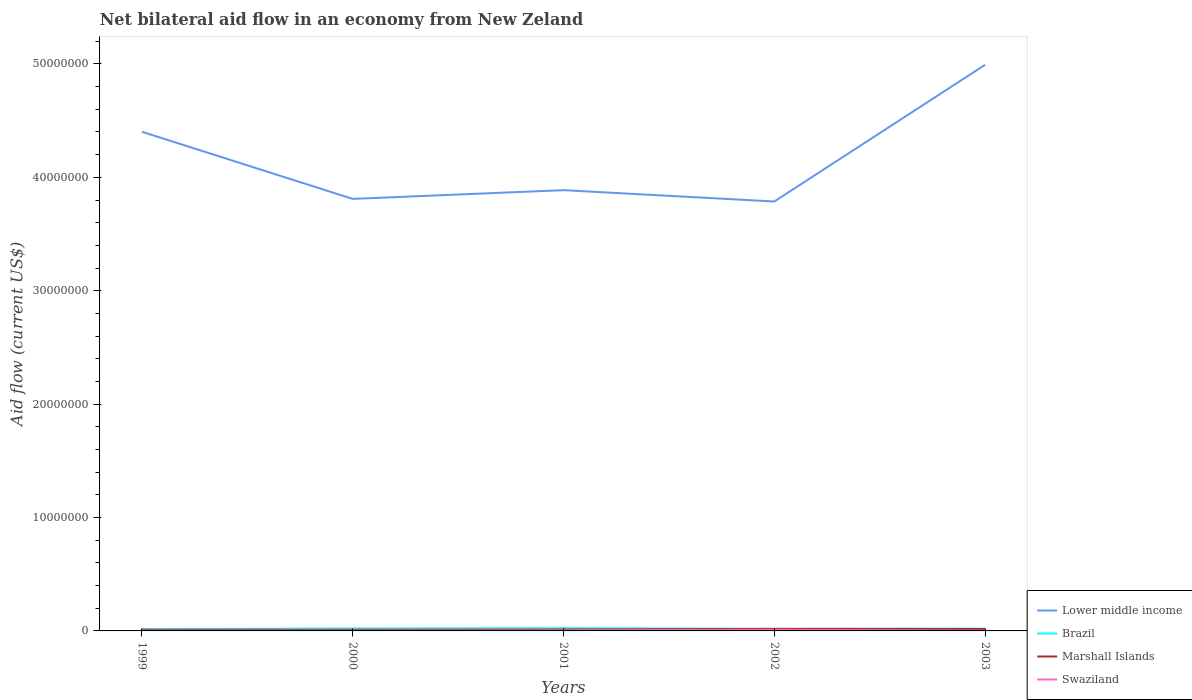How many different coloured lines are there?
Provide a short and direct response. 4. Does the line corresponding to Swaziland intersect with the line corresponding to Lower middle income?
Keep it short and to the point. No. Across all years, what is the maximum net bilateral aid flow in Swaziland?
Ensure brevity in your answer.  2.00e+04. In which year was the net bilateral aid flow in Lower middle income maximum?
Make the answer very short. 2002. What is the total net bilateral aid flow in Lower middle income in the graph?
Provide a short and direct response. -1.10e+07. What is the difference between the highest and the second highest net bilateral aid flow in Brazil?
Provide a succinct answer. 7.00e+04. What is the difference between the highest and the lowest net bilateral aid flow in Lower middle income?
Offer a very short reply. 2. Is the net bilateral aid flow in Swaziland strictly greater than the net bilateral aid flow in Lower middle income over the years?
Provide a short and direct response. Yes. How many lines are there?
Keep it short and to the point. 4. How many years are there in the graph?
Keep it short and to the point. 5. Does the graph contain any zero values?
Provide a succinct answer. No. Where does the legend appear in the graph?
Your answer should be compact. Bottom right. What is the title of the graph?
Provide a succinct answer. Net bilateral aid flow in an economy from New Zeland. Does "Nepal" appear as one of the legend labels in the graph?
Your answer should be compact. No. What is the label or title of the Y-axis?
Give a very brief answer. Aid flow (current US$). What is the Aid flow (current US$) in Lower middle income in 1999?
Keep it short and to the point. 4.40e+07. What is the Aid flow (current US$) of Brazil in 1999?
Your response must be concise. 1.70e+05. What is the Aid flow (current US$) of Marshall Islands in 1999?
Your answer should be compact. 1.00e+05. What is the Aid flow (current US$) of Lower middle income in 2000?
Ensure brevity in your answer.  3.81e+07. What is the Aid flow (current US$) in Marshall Islands in 2000?
Keep it short and to the point. 1.00e+05. What is the Aid flow (current US$) in Lower middle income in 2001?
Give a very brief answer. 3.89e+07. What is the Aid flow (current US$) of Brazil in 2001?
Give a very brief answer. 2.40e+05. What is the Aid flow (current US$) in Swaziland in 2001?
Provide a short and direct response. 5.00e+04. What is the Aid flow (current US$) of Lower middle income in 2002?
Make the answer very short. 3.79e+07. What is the Aid flow (current US$) in Brazil in 2002?
Provide a short and direct response. 1.80e+05. What is the Aid flow (current US$) of Marshall Islands in 2002?
Offer a very short reply. 1.80e+05. What is the Aid flow (current US$) in Swaziland in 2002?
Your answer should be very brief. 1.00e+05. What is the Aid flow (current US$) in Lower middle income in 2003?
Provide a short and direct response. 4.99e+07. Across all years, what is the maximum Aid flow (current US$) in Lower middle income?
Keep it short and to the point. 4.99e+07. Across all years, what is the maximum Aid flow (current US$) of Brazil?
Your answer should be compact. 2.40e+05. Across all years, what is the minimum Aid flow (current US$) of Lower middle income?
Your answer should be very brief. 3.79e+07. Across all years, what is the minimum Aid flow (current US$) in Marshall Islands?
Provide a short and direct response. 1.00e+05. What is the total Aid flow (current US$) in Lower middle income in the graph?
Make the answer very short. 2.09e+08. What is the total Aid flow (current US$) of Marshall Islands in the graph?
Provide a short and direct response. 6.70e+05. What is the total Aid flow (current US$) of Swaziland in the graph?
Keep it short and to the point. 2.30e+05. What is the difference between the Aid flow (current US$) of Lower middle income in 1999 and that in 2000?
Your answer should be very brief. 5.92e+06. What is the difference between the Aid flow (current US$) in Brazil in 1999 and that in 2000?
Offer a terse response. -4.00e+04. What is the difference between the Aid flow (current US$) of Marshall Islands in 1999 and that in 2000?
Ensure brevity in your answer.  0. What is the difference between the Aid flow (current US$) in Swaziland in 1999 and that in 2000?
Offer a terse response. 0. What is the difference between the Aid flow (current US$) of Lower middle income in 1999 and that in 2001?
Make the answer very short. 5.15e+06. What is the difference between the Aid flow (current US$) in Brazil in 1999 and that in 2001?
Give a very brief answer. -7.00e+04. What is the difference between the Aid flow (current US$) in Marshall Islands in 1999 and that in 2001?
Your answer should be compact. -2.00e+04. What is the difference between the Aid flow (current US$) in Lower middle income in 1999 and that in 2002?
Keep it short and to the point. 6.15e+06. What is the difference between the Aid flow (current US$) in Lower middle income in 1999 and that in 2003?
Your answer should be compact. -5.90e+06. What is the difference between the Aid flow (current US$) of Brazil in 1999 and that in 2003?
Your response must be concise. -3.00e+04. What is the difference between the Aid flow (current US$) in Lower middle income in 2000 and that in 2001?
Provide a short and direct response. -7.70e+05. What is the difference between the Aid flow (current US$) in Brazil in 2000 and that in 2001?
Your response must be concise. -3.00e+04. What is the difference between the Aid flow (current US$) of Marshall Islands in 2000 and that in 2001?
Your answer should be very brief. -2.00e+04. What is the difference between the Aid flow (current US$) of Lower middle income in 2000 and that in 2002?
Give a very brief answer. 2.30e+05. What is the difference between the Aid flow (current US$) of Swaziland in 2000 and that in 2002?
Ensure brevity in your answer.  -7.00e+04. What is the difference between the Aid flow (current US$) in Lower middle income in 2000 and that in 2003?
Your answer should be compact. -1.18e+07. What is the difference between the Aid flow (current US$) in Marshall Islands in 2000 and that in 2003?
Provide a succinct answer. -7.00e+04. What is the difference between the Aid flow (current US$) of Lower middle income in 2001 and that in 2002?
Ensure brevity in your answer.  1.00e+06. What is the difference between the Aid flow (current US$) of Marshall Islands in 2001 and that in 2002?
Offer a very short reply. -6.00e+04. What is the difference between the Aid flow (current US$) in Swaziland in 2001 and that in 2002?
Keep it short and to the point. -5.00e+04. What is the difference between the Aid flow (current US$) in Lower middle income in 2001 and that in 2003?
Give a very brief answer. -1.10e+07. What is the difference between the Aid flow (current US$) of Lower middle income in 2002 and that in 2003?
Provide a short and direct response. -1.20e+07. What is the difference between the Aid flow (current US$) of Marshall Islands in 2002 and that in 2003?
Ensure brevity in your answer.  10000. What is the difference between the Aid flow (current US$) in Swaziland in 2002 and that in 2003?
Offer a terse response. 8.00e+04. What is the difference between the Aid flow (current US$) in Lower middle income in 1999 and the Aid flow (current US$) in Brazil in 2000?
Your response must be concise. 4.38e+07. What is the difference between the Aid flow (current US$) of Lower middle income in 1999 and the Aid flow (current US$) of Marshall Islands in 2000?
Provide a short and direct response. 4.39e+07. What is the difference between the Aid flow (current US$) in Lower middle income in 1999 and the Aid flow (current US$) in Swaziland in 2000?
Make the answer very short. 4.40e+07. What is the difference between the Aid flow (current US$) of Brazil in 1999 and the Aid flow (current US$) of Marshall Islands in 2000?
Provide a short and direct response. 7.00e+04. What is the difference between the Aid flow (current US$) of Brazil in 1999 and the Aid flow (current US$) of Swaziland in 2000?
Offer a very short reply. 1.40e+05. What is the difference between the Aid flow (current US$) in Lower middle income in 1999 and the Aid flow (current US$) in Brazil in 2001?
Your response must be concise. 4.38e+07. What is the difference between the Aid flow (current US$) in Lower middle income in 1999 and the Aid flow (current US$) in Marshall Islands in 2001?
Your response must be concise. 4.39e+07. What is the difference between the Aid flow (current US$) in Lower middle income in 1999 and the Aid flow (current US$) in Swaziland in 2001?
Your answer should be very brief. 4.40e+07. What is the difference between the Aid flow (current US$) in Brazil in 1999 and the Aid flow (current US$) in Marshall Islands in 2001?
Give a very brief answer. 5.00e+04. What is the difference between the Aid flow (current US$) of Lower middle income in 1999 and the Aid flow (current US$) of Brazil in 2002?
Your answer should be compact. 4.38e+07. What is the difference between the Aid flow (current US$) in Lower middle income in 1999 and the Aid flow (current US$) in Marshall Islands in 2002?
Provide a succinct answer. 4.38e+07. What is the difference between the Aid flow (current US$) in Lower middle income in 1999 and the Aid flow (current US$) in Swaziland in 2002?
Provide a short and direct response. 4.39e+07. What is the difference between the Aid flow (current US$) in Brazil in 1999 and the Aid flow (current US$) in Marshall Islands in 2002?
Offer a very short reply. -10000. What is the difference between the Aid flow (current US$) in Marshall Islands in 1999 and the Aid flow (current US$) in Swaziland in 2002?
Make the answer very short. 0. What is the difference between the Aid flow (current US$) in Lower middle income in 1999 and the Aid flow (current US$) in Brazil in 2003?
Ensure brevity in your answer.  4.38e+07. What is the difference between the Aid flow (current US$) of Lower middle income in 1999 and the Aid flow (current US$) of Marshall Islands in 2003?
Make the answer very short. 4.38e+07. What is the difference between the Aid flow (current US$) in Lower middle income in 1999 and the Aid flow (current US$) in Swaziland in 2003?
Your answer should be very brief. 4.40e+07. What is the difference between the Aid flow (current US$) in Brazil in 1999 and the Aid flow (current US$) in Swaziland in 2003?
Ensure brevity in your answer.  1.50e+05. What is the difference between the Aid flow (current US$) in Lower middle income in 2000 and the Aid flow (current US$) in Brazil in 2001?
Your response must be concise. 3.79e+07. What is the difference between the Aid flow (current US$) of Lower middle income in 2000 and the Aid flow (current US$) of Marshall Islands in 2001?
Your answer should be compact. 3.80e+07. What is the difference between the Aid flow (current US$) in Lower middle income in 2000 and the Aid flow (current US$) in Swaziland in 2001?
Your response must be concise. 3.80e+07. What is the difference between the Aid flow (current US$) of Marshall Islands in 2000 and the Aid flow (current US$) of Swaziland in 2001?
Your answer should be compact. 5.00e+04. What is the difference between the Aid flow (current US$) in Lower middle income in 2000 and the Aid flow (current US$) in Brazil in 2002?
Keep it short and to the point. 3.79e+07. What is the difference between the Aid flow (current US$) of Lower middle income in 2000 and the Aid flow (current US$) of Marshall Islands in 2002?
Your answer should be very brief. 3.79e+07. What is the difference between the Aid flow (current US$) of Lower middle income in 2000 and the Aid flow (current US$) of Swaziland in 2002?
Keep it short and to the point. 3.80e+07. What is the difference between the Aid flow (current US$) of Lower middle income in 2000 and the Aid flow (current US$) of Brazil in 2003?
Provide a short and direct response. 3.79e+07. What is the difference between the Aid flow (current US$) of Lower middle income in 2000 and the Aid flow (current US$) of Marshall Islands in 2003?
Offer a terse response. 3.79e+07. What is the difference between the Aid flow (current US$) of Lower middle income in 2000 and the Aid flow (current US$) of Swaziland in 2003?
Keep it short and to the point. 3.81e+07. What is the difference between the Aid flow (current US$) in Brazil in 2000 and the Aid flow (current US$) in Marshall Islands in 2003?
Your response must be concise. 4.00e+04. What is the difference between the Aid flow (current US$) in Brazil in 2000 and the Aid flow (current US$) in Swaziland in 2003?
Your response must be concise. 1.90e+05. What is the difference between the Aid flow (current US$) of Marshall Islands in 2000 and the Aid flow (current US$) of Swaziland in 2003?
Give a very brief answer. 8.00e+04. What is the difference between the Aid flow (current US$) in Lower middle income in 2001 and the Aid flow (current US$) in Brazil in 2002?
Give a very brief answer. 3.87e+07. What is the difference between the Aid flow (current US$) of Lower middle income in 2001 and the Aid flow (current US$) of Marshall Islands in 2002?
Give a very brief answer. 3.87e+07. What is the difference between the Aid flow (current US$) of Lower middle income in 2001 and the Aid flow (current US$) of Swaziland in 2002?
Your answer should be compact. 3.88e+07. What is the difference between the Aid flow (current US$) in Marshall Islands in 2001 and the Aid flow (current US$) in Swaziland in 2002?
Your response must be concise. 2.00e+04. What is the difference between the Aid flow (current US$) in Lower middle income in 2001 and the Aid flow (current US$) in Brazil in 2003?
Your answer should be very brief. 3.87e+07. What is the difference between the Aid flow (current US$) of Lower middle income in 2001 and the Aid flow (current US$) of Marshall Islands in 2003?
Provide a short and direct response. 3.87e+07. What is the difference between the Aid flow (current US$) of Lower middle income in 2001 and the Aid flow (current US$) of Swaziland in 2003?
Offer a terse response. 3.88e+07. What is the difference between the Aid flow (current US$) of Brazil in 2001 and the Aid flow (current US$) of Marshall Islands in 2003?
Keep it short and to the point. 7.00e+04. What is the difference between the Aid flow (current US$) of Brazil in 2001 and the Aid flow (current US$) of Swaziland in 2003?
Offer a very short reply. 2.20e+05. What is the difference between the Aid flow (current US$) of Marshall Islands in 2001 and the Aid flow (current US$) of Swaziland in 2003?
Your answer should be compact. 1.00e+05. What is the difference between the Aid flow (current US$) in Lower middle income in 2002 and the Aid flow (current US$) in Brazil in 2003?
Offer a terse response. 3.77e+07. What is the difference between the Aid flow (current US$) in Lower middle income in 2002 and the Aid flow (current US$) in Marshall Islands in 2003?
Your response must be concise. 3.77e+07. What is the difference between the Aid flow (current US$) of Lower middle income in 2002 and the Aid flow (current US$) of Swaziland in 2003?
Make the answer very short. 3.78e+07. What is the difference between the Aid flow (current US$) of Brazil in 2002 and the Aid flow (current US$) of Marshall Islands in 2003?
Offer a terse response. 10000. What is the difference between the Aid flow (current US$) of Marshall Islands in 2002 and the Aid flow (current US$) of Swaziland in 2003?
Offer a very short reply. 1.60e+05. What is the average Aid flow (current US$) in Lower middle income per year?
Your response must be concise. 4.18e+07. What is the average Aid flow (current US$) in Marshall Islands per year?
Your answer should be very brief. 1.34e+05. What is the average Aid flow (current US$) in Swaziland per year?
Offer a terse response. 4.60e+04. In the year 1999, what is the difference between the Aid flow (current US$) of Lower middle income and Aid flow (current US$) of Brazil?
Offer a terse response. 4.38e+07. In the year 1999, what is the difference between the Aid flow (current US$) in Lower middle income and Aid flow (current US$) in Marshall Islands?
Provide a short and direct response. 4.39e+07. In the year 1999, what is the difference between the Aid flow (current US$) in Lower middle income and Aid flow (current US$) in Swaziland?
Your answer should be very brief. 4.40e+07. In the year 1999, what is the difference between the Aid flow (current US$) in Brazil and Aid flow (current US$) in Marshall Islands?
Provide a short and direct response. 7.00e+04. In the year 2000, what is the difference between the Aid flow (current US$) of Lower middle income and Aid flow (current US$) of Brazil?
Keep it short and to the point. 3.79e+07. In the year 2000, what is the difference between the Aid flow (current US$) of Lower middle income and Aid flow (current US$) of Marshall Islands?
Offer a terse response. 3.80e+07. In the year 2000, what is the difference between the Aid flow (current US$) of Lower middle income and Aid flow (current US$) of Swaziland?
Offer a terse response. 3.81e+07. In the year 2000, what is the difference between the Aid flow (current US$) of Brazil and Aid flow (current US$) of Swaziland?
Provide a short and direct response. 1.80e+05. In the year 2000, what is the difference between the Aid flow (current US$) of Marshall Islands and Aid flow (current US$) of Swaziland?
Give a very brief answer. 7.00e+04. In the year 2001, what is the difference between the Aid flow (current US$) of Lower middle income and Aid flow (current US$) of Brazil?
Make the answer very short. 3.86e+07. In the year 2001, what is the difference between the Aid flow (current US$) in Lower middle income and Aid flow (current US$) in Marshall Islands?
Keep it short and to the point. 3.88e+07. In the year 2001, what is the difference between the Aid flow (current US$) of Lower middle income and Aid flow (current US$) of Swaziland?
Your answer should be very brief. 3.88e+07. In the year 2001, what is the difference between the Aid flow (current US$) in Marshall Islands and Aid flow (current US$) in Swaziland?
Provide a succinct answer. 7.00e+04. In the year 2002, what is the difference between the Aid flow (current US$) of Lower middle income and Aid flow (current US$) of Brazil?
Your response must be concise. 3.77e+07. In the year 2002, what is the difference between the Aid flow (current US$) of Lower middle income and Aid flow (current US$) of Marshall Islands?
Offer a very short reply. 3.77e+07. In the year 2002, what is the difference between the Aid flow (current US$) of Lower middle income and Aid flow (current US$) of Swaziland?
Your answer should be compact. 3.78e+07. In the year 2002, what is the difference between the Aid flow (current US$) of Brazil and Aid flow (current US$) of Marshall Islands?
Ensure brevity in your answer.  0. In the year 2002, what is the difference between the Aid flow (current US$) in Brazil and Aid flow (current US$) in Swaziland?
Your answer should be compact. 8.00e+04. In the year 2002, what is the difference between the Aid flow (current US$) in Marshall Islands and Aid flow (current US$) in Swaziland?
Provide a succinct answer. 8.00e+04. In the year 2003, what is the difference between the Aid flow (current US$) of Lower middle income and Aid flow (current US$) of Brazil?
Make the answer very short. 4.97e+07. In the year 2003, what is the difference between the Aid flow (current US$) of Lower middle income and Aid flow (current US$) of Marshall Islands?
Your response must be concise. 4.98e+07. In the year 2003, what is the difference between the Aid flow (current US$) in Lower middle income and Aid flow (current US$) in Swaziland?
Ensure brevity in your answer.  4.99e+07. In the year 2003, what is the difference between the Aid flow (current US$) in Brazil and Aid flow (current US$) in Marshall Islands?
Provide a succinct answer. 3.00e+04. In the year 2003, what is the difference between the Aid flow (current US$) of Brazil and Aid flow (current US$) of Swaziland?
Offer a very short reply. 1.80e+05. In the year 2003, what is the difference between the Aid flow (current US$) of Marshall Islands and Aid flow (current US$) of Swaziland?
Give a very brief answer. 1.50e+05. What is the ratio of the Aid flow (current US$) in Lower middle income in 1999 to that in 2000?
Provide a succinct answer. 1.16. What is the ratio of the Aid flow (current US$) in Brazil in 1999 to that in 2000?
Your response must be concise. 0.81. What is the ratio of the Aid flow (current US$) of Lower middle income in 1999 to that in 2001?
Offer a very short reply. 1.13. What is the ratio of the Aid flow (current US$) of Brazil in 1999 to that in 2001?
Provide a short and direct response. 0.71. What is the ratio of the Aid flow (current US$) in Lower middle income in 1999 to that in 2002?
Your response must be concise. 1.16. What is the ratio of the Aid flow (current US$) of Brazil in 1999 to that in 2002?
Offer a terse response. 0.94. What is the ratio of the Aid flow (current US$) in Marshall Islands in 1999 to that in 2002?
Ensure brevity in your answer.  0.56. What is the ratio of the Aid flow (current US$) in Swaziland in 1999 to that in 2002?
Provide a short and direct response. 0.3. What is the ratio of the Aid flow (current US$) of Lower middle income in 1999 to that in 2003?
Provide a short and direct response. 0.88. What is the ratio of the Aid flow (current US$) in Marshall Islands in 1999 to that in 2003?
Provide a succinct answer. 0.59. What is the ratio of the Aid flow (current US$) in Swaziland in 1999 to that in 2003?
Offer a very short reply. 1.5. What is the ratio of the Aid flow (current US$) in Lower middle income in 2000 to that in 2001?
Provide a succinct answer. 0.98. What is the ratio of the Aid flow (current US$) of Marshall Islands in 2000 to that in 2001?
Offer a very short reply. 0.83. What is the ratio of the Aid flow (current US$) in Lower middle income in 2000 to that in 2002?
Your response must be concise. 1.01. What is the ratio of the Aid flow (current US$) in Brazil in 2000 to that in 2002?
Your answer should be compact. 1.17. What is the ratio of the Aid flow (current US$) in Marshall Islands in 2000 to that in 2002?
Offer a terse response. 0.56. What is the ratio of the Aid flow (current US$) in Lower middle income in 2000 to that in 2003?
Your answer should be very brief. 0.76. What is the ratio of the Aid flow (current US$) in Marshall Islands in 2000 to that in 2003?
Keep it short and to the point. 0.59. What is the ratio of the Aid flow (current US$) in Swaziland in 2000 to that in 2003?
Provide a succinct answer. 1.5. What is the ratio of the Aid flow (current US$) in Lower middle income in 2001 to that in 2002?
Your answer should be very brief. 1.03. What is the ratio of the Aid flow (current US$) of Marshall Islands in 2001 to that in 2002?
Offer a very short reply. 0.67. What is the ratio of the Aid flow (current US$) in Lower middle income in 2001 to that in 2003?
Give a very brief answer. 0.78. What is the ratio of the Aid flow (current US$) of Marshall Islands in 2001 to that in 2003?
Keep it short and to the point. 0.71. What is the ratio of the Aid flow (current US$) of Lower middle income in 2002 to that in 2003?
Your answer should be compact. 0.76. What is the ratio of the Aid flow (current US$) in Marshall Islands in 2002 to that in 2003?
Offer a terse response. 1.06. What is the ratio of the Aid flow (current US$) in Swaziland in 2002 to that in 2003?
Keep it short and to the point. 5. What is the difference between the highest and the second highest Aid flow (current US$) of Lower middle income?
Your answer should be compact. 5.90e+06. What is the difference between the highest and the second highest Aid flow (current US$) in Brazil?
Give a very brief answer. 3.00e+04. What is the difference between the highest and the second highest Aid flow (current US$) of Marshall Islands?
Make the answer very short. 10000. What is the difference between the highest and the lowest Aid flow (current US$) in Lower middle income?
Your answer should be very brief. 1.20e+07. What is the difference between the highest and the lowest Aid flow (current US$) of Marshall Islands?
Your answer should be compact. 8.00e+04. 